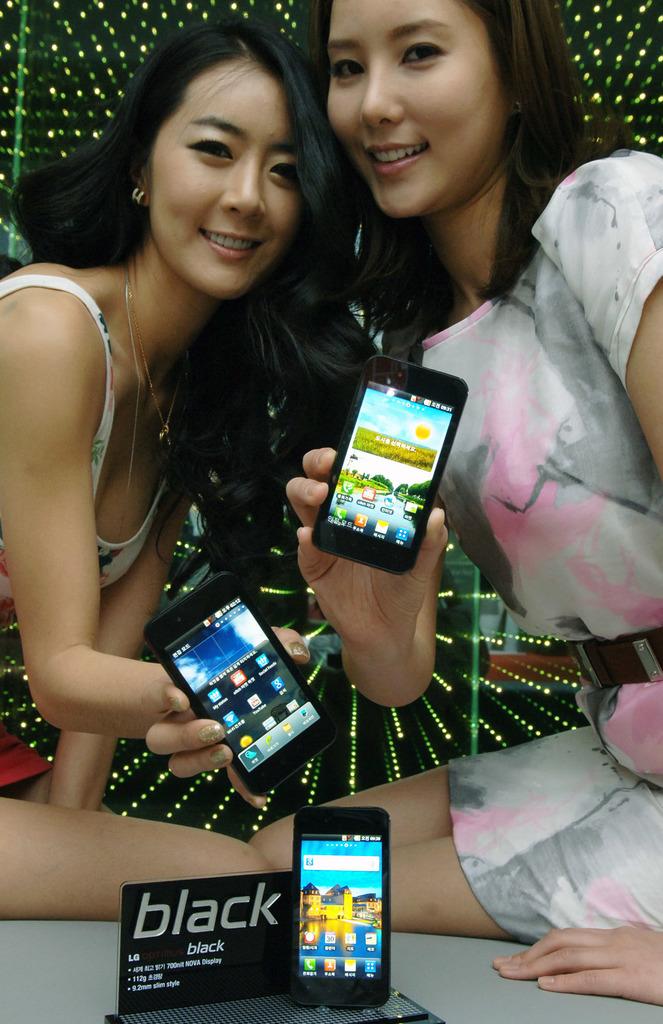What is the brand being advertised here?
Make the answer very short. Lg. What color is on the sign?
Provide a succinct answer. Black. 